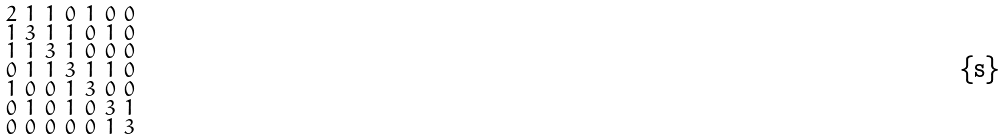<formula> <loc_0><loc_0><loc_500><loc_500>\begin{smallmatrix} 2 & 1 & 1 & 0 & 1 & 0 & 0 \\ 1 & 3 & 1 & 1 & 0 & 1 & 0 \\ 1 & 1 & 3 & 1 & 0 & 0 & 0 \\ 0 & 1 & 1 & 3 & 1 & 1 & 0 \\ 1 & 0 & 0 & 1 & 3 & 0 & 0 \\ 0 & 1 & 0 & 1 & 0 & 3 & 1 \\ 0 & 0 & 0 & 0 & 0 & 1 & 3 \end{smallmatrix}</formula> 